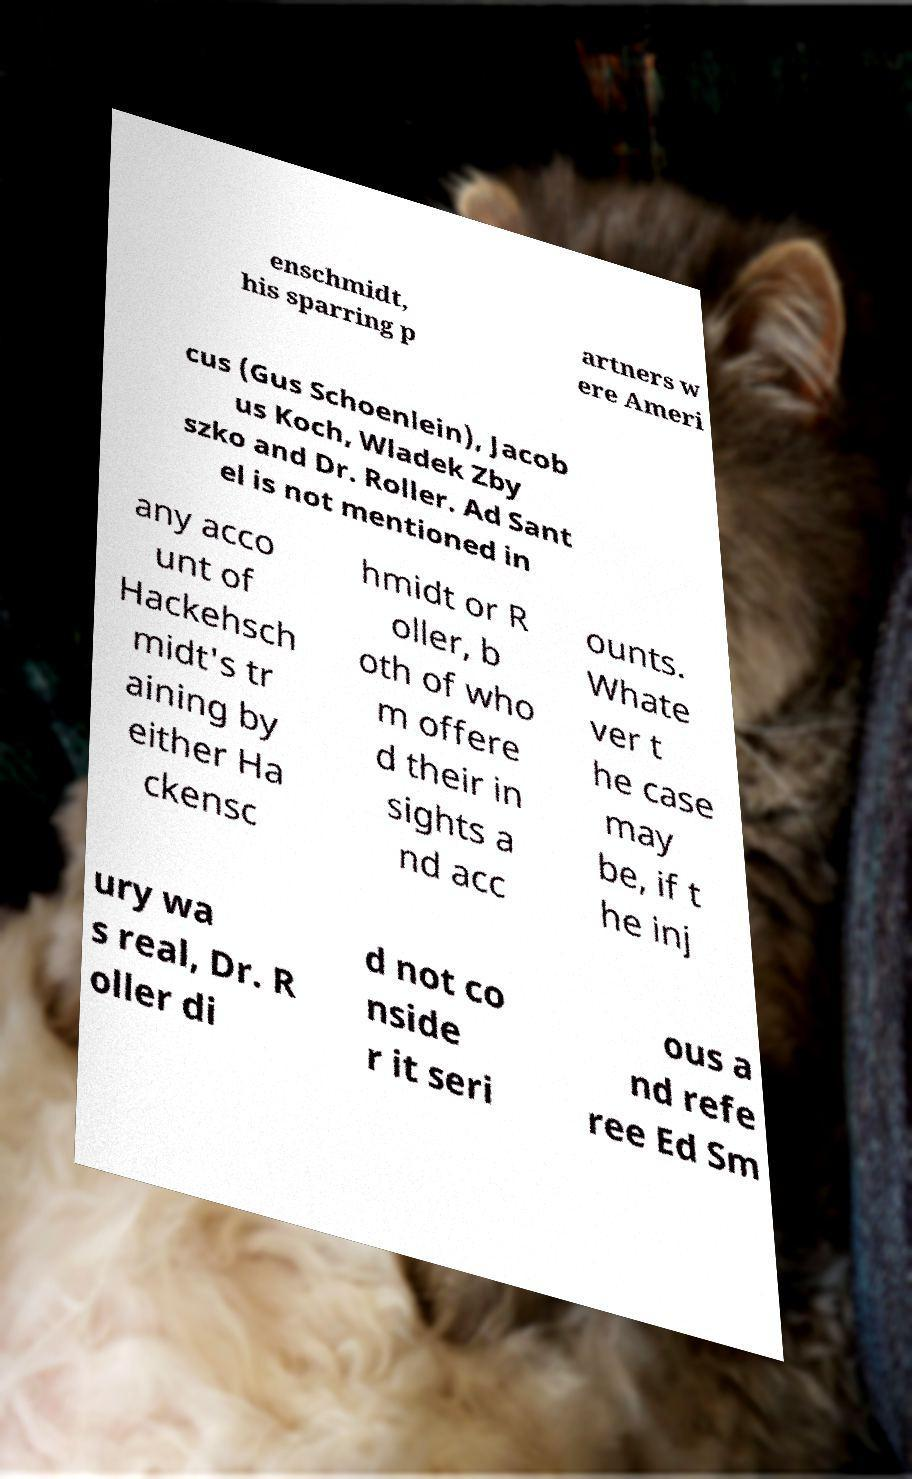There's text embedded in this image that I need extracted. Can you transcribe it verbatim? enschmidt, his sparring p artners w ere Ameri cus (Gus Schoenlein), Jacob us Koch, Wladek Zby szko and Dr. Roller. Ad Sant el is not mentioned in any acco unt of Hackehsch midt's tr aining by either Ha ckensc hmidt or R oller, b oth of who m offere d their in sights a nd acc ounts. Whate ver t he case may be, if t he inj ury wa s real, Dr. R oller di d not co nside r it seri ous a nd refe ree Ed Sm 